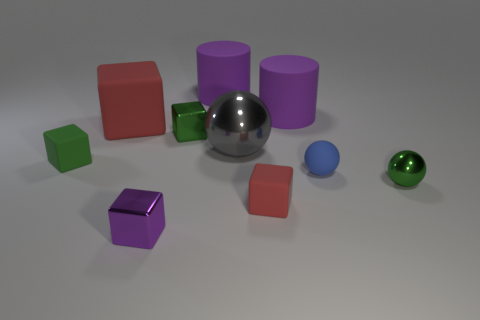There is a green thing that is the same shape as the gray metal object; what size is it?
Your response must be concise. Small. There is a green shiny object in front of the blue ball; how big is it?
Offer a terse response. Small. Is the number of big gray metallic balls that are left of the gray thing greater than the number of tiny cyan matte cylinders?
Provide a succinct answer. No. The purple metal thing has what shape?
Offer a terse response. Cube. Is the color of the small rubber block right of the big red object the same as the tiny metal cube that is right of the tiny purple metallic object?
Your answer should be compact. No. Is the blue rubber object the same shape as the green matte thing?
Offer a terse response. No. Is there any other thing that is the same shape as the small green matte thing?
Your response must be concise. Yes. Is the material of the red object behind the tiny green matte block the same as the small red object?
Provide a short and direct response. Yes. What shape is the small matte thing that is both right of the small purple cube and behind the tiny red cube?
Your answer should be very brief. Sphere. Are there any big cylinders in front of the large purple matte cylinder that is left of the large gray ball?
Your response must be concise. Yes. 